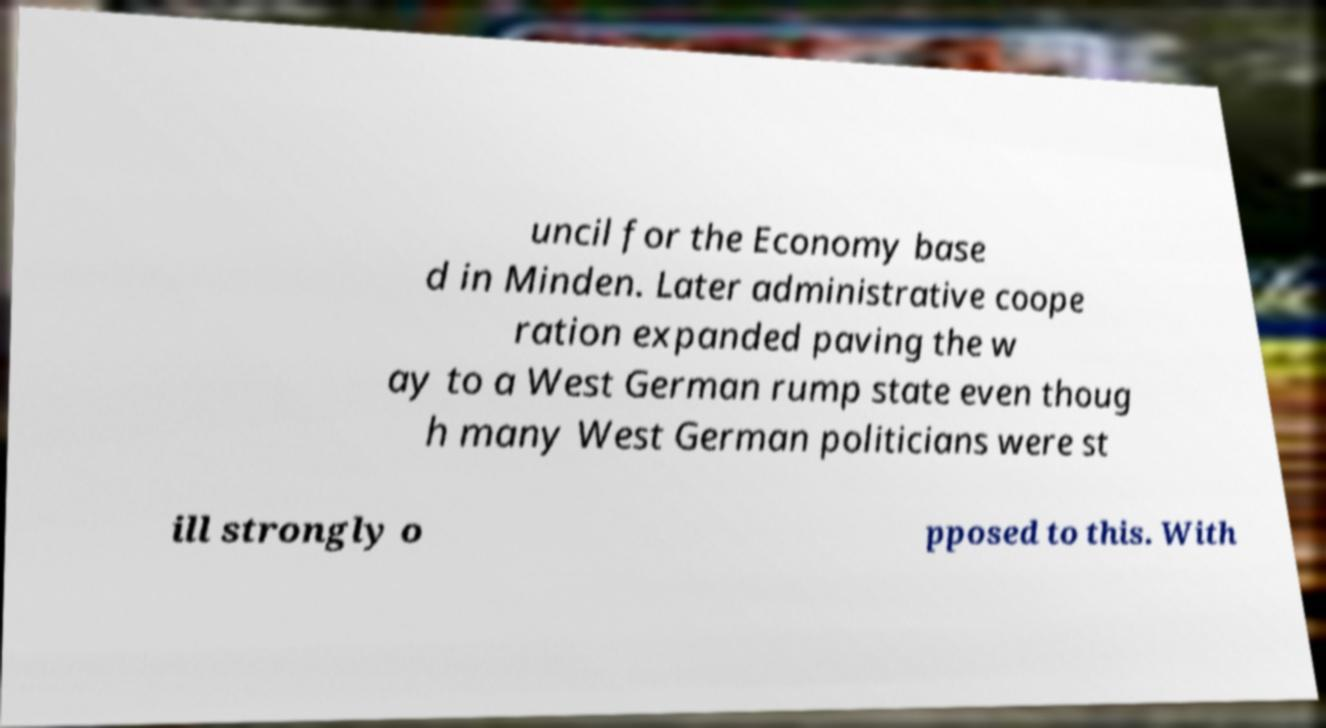Please read and relay the text visible in this image. What does it say? uncil for the Economy base d in Minden. Later administrative coope ration expanded paving the w ay to a West German rump state even thoug h many West German politicians were st ill strongly o pposed to this. With 